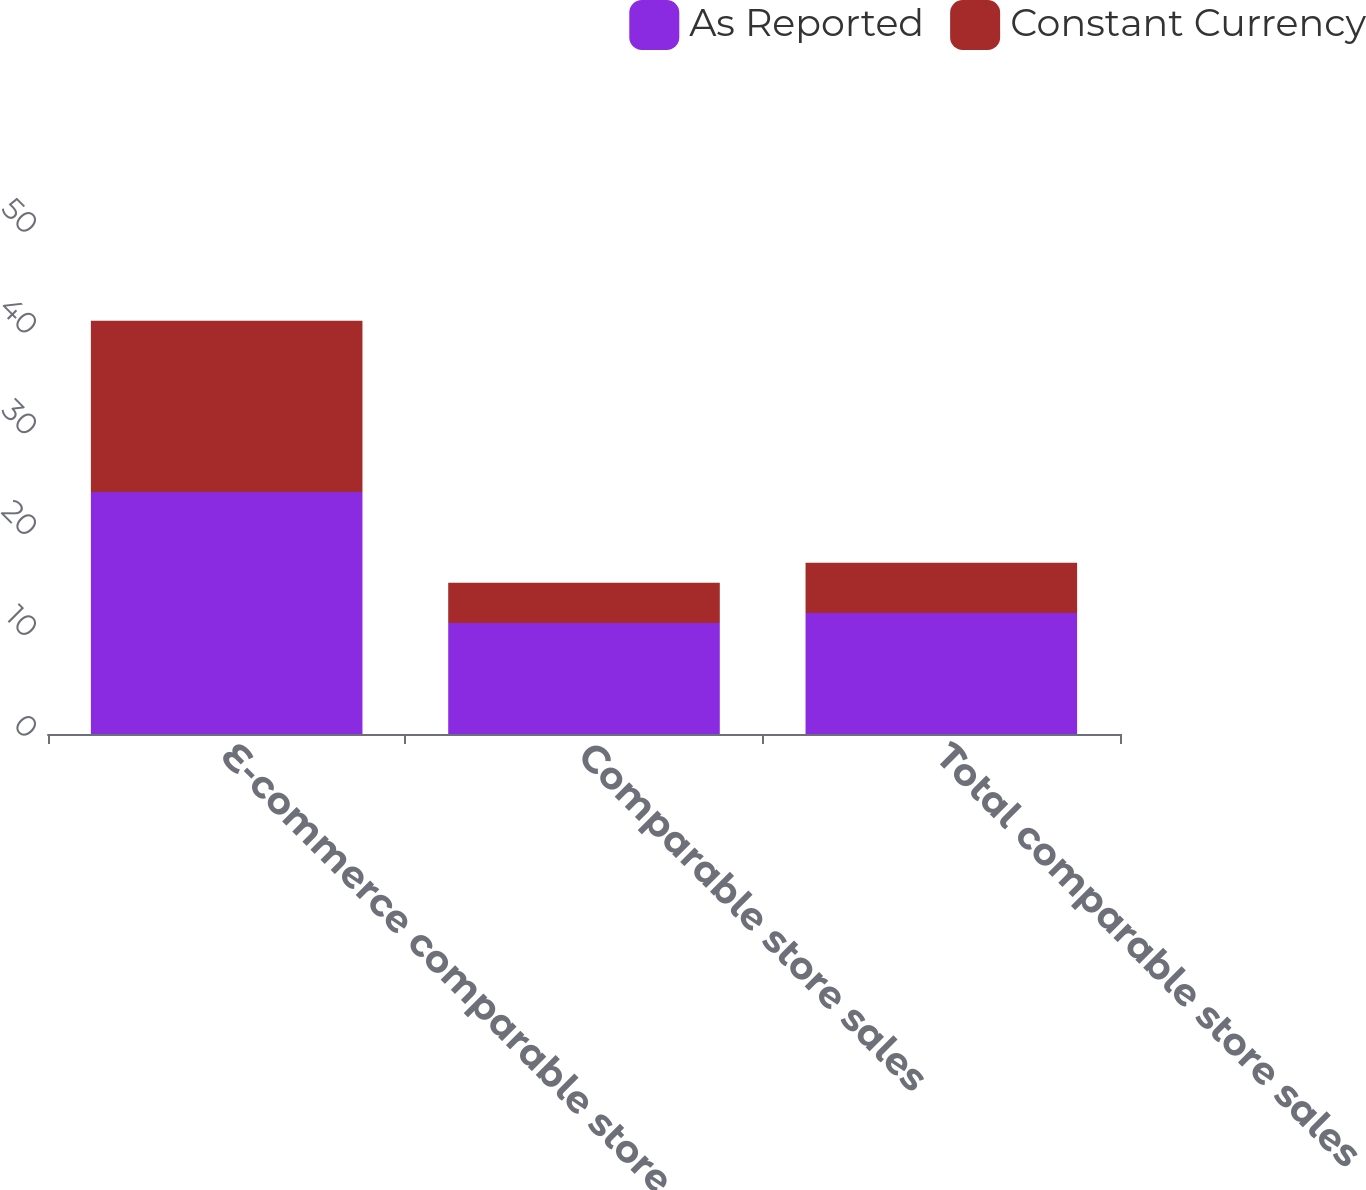Convert chart. <chart><loc_0><loc_0><loc_500><loc_500><stacked_bar_chart><ecel><fcel>E-commerce comparable store<fcel>Comparable store sales<fcel>Total comparable store sales<nl><fcel>As Reported<fcel>24<fcel>11<fcel>12<nl><fcel>Constant Currency<fcel>17<fcel>4<fcel>5<nl></chart> 